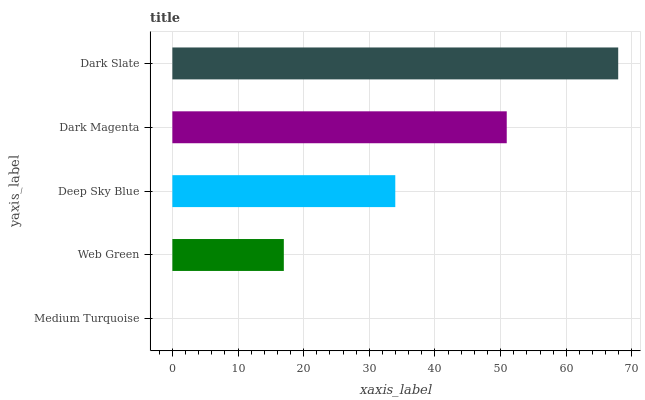Is Medium Turquoise the minimum?
Answer yes or no. Yes. Is Dark Slate the maximum?
Answer yes or no. Yes. Is Web Green the minimum?
Answer yes or no. No. Is Web Green the maximum?
Answer yes or no. No. Is Web Green greater than Medium Turquoise?
Answer yes or no. Yes. Is Medium Turquoise less than Web Green?
Answer yes or no. Yes. Is Medium Turquoise greater than Web Green?
Answer yes or no. No. Is Web Green less than Medium Turquoise?
Answer yes or no. No. Is Deep Sky Blue the high median?
Answer yes or no. Yes. Is Deep Sky Blue the low median?
Answer yes or no. Yes. Is Dark Slate the high median?
Answer yes or no. No. Is Web Green the low median?
Answer yes or no. No. 